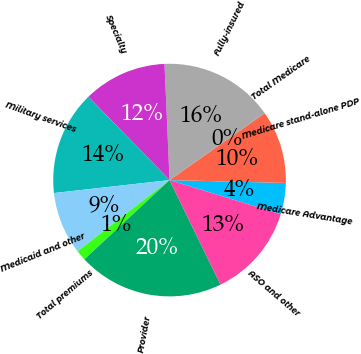<chart> <loc_0><loc_0><loc_500><loc_500><pie_chart><fcel>Medicare Advantage<fcel>Medicare stand-alone PDP<fcel>Total Medicare<fcel>Fully-insured<fcel>Specialty<fcel>Military services<fcel>Medicaid and other<fcel>Total premiums<fcel>Provider<fcel>ASO and other<nl><fcel>4.35%<fcel>10.14%<fcel>0.0%<fcel>15.94%<fcel>11.59%<fcel>14.49%<fcel>8.7%<fcel>1.45%<fcel>20.29%<fcel>13.04%<nl></chart> 